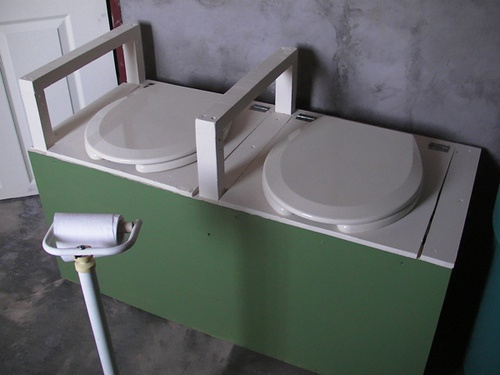Describe the objects in this image and their specific colors. I can see toilet in darkgray, gray, and black tones and toilet in darkgray, lightgray, and gray tones in this image. 